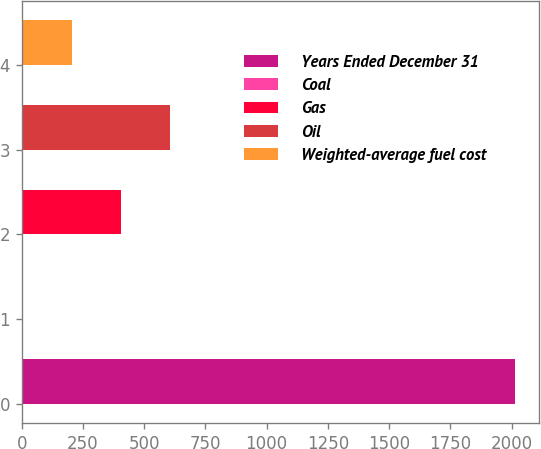Convert chart. <chart><loc_0><loc_0><loc_500><loc_500><bar_chart><fcel>Years Ended December 31<fcel>Coal<fcel>Gas<fcel>Oil<fcel>Weighted-average fuel cost<nl><fcel>2013<fcel>2.9<fcel>404.92<fcel>605.93<fcel>203.91<nl></chart> 